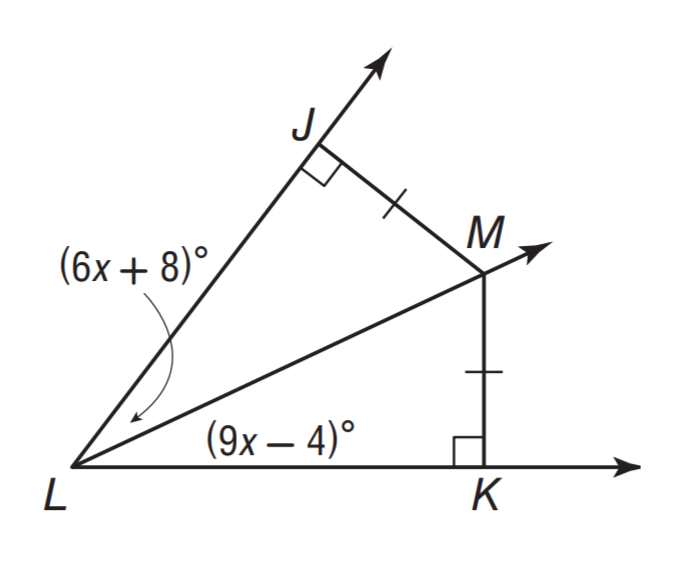Question: What is the measure of \angle K L M.
Choices:
A. 32
B. 44
C. 78
D. 94
Answer with the letter. Answer: A 